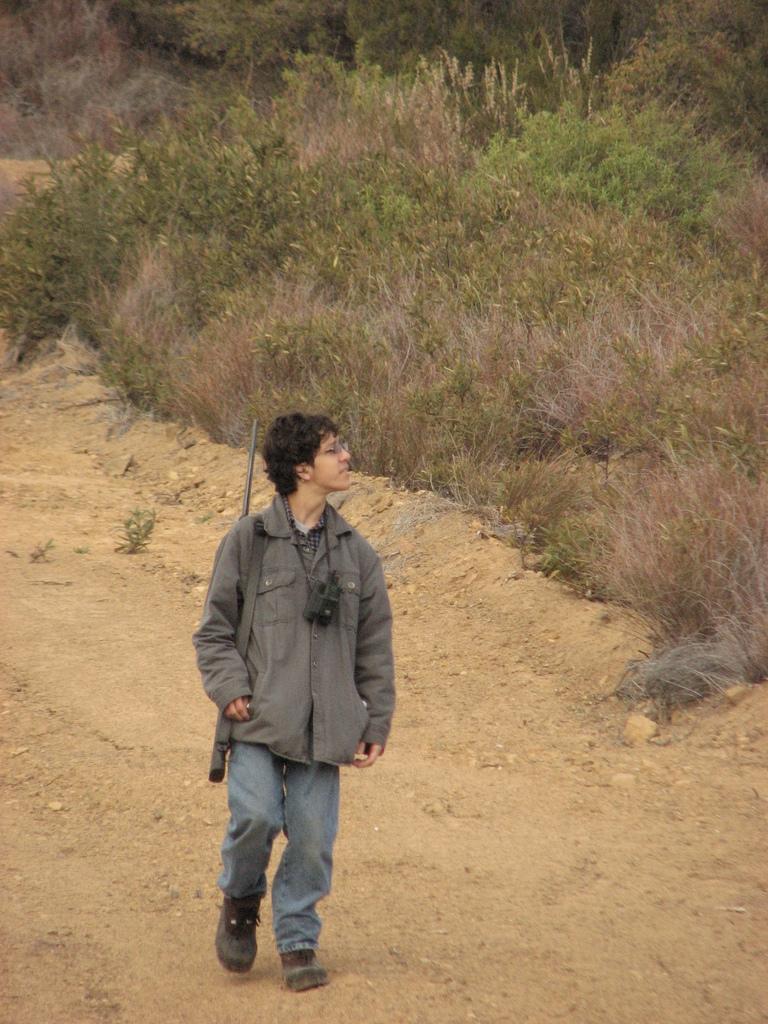Please provide a concise description of this image. In this image we can see a man is walking on the land. He is wearing a jacket, jeans and carrying a gun and a camera. In the background, we can see grass, plants and trees. 